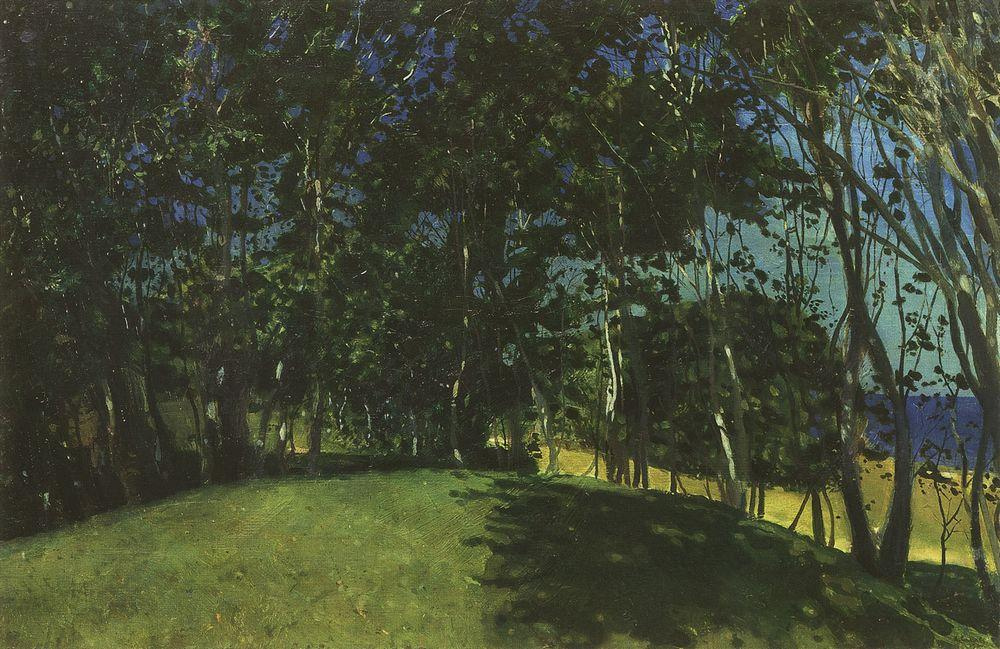Can you tell me more about the style and possible inspirations for this painting? The painting is distinguished by its loose brushwork and vivid portrayal of light, which are hallmarks of the post-impressionist movement that succeeded impressionism. The artist may have been inspired by the likes of Vincent van Gogh or Paul Cézanne, who were known for their innovative use of color and form to convey emotion and structure in their depictions of the natural world. Unlike the fleeting impressions captured by earlier impressionists, post-impressionists often sought to imbue their work with a sense of permanence and structure, while still honoring the light and color of their surroundings. 